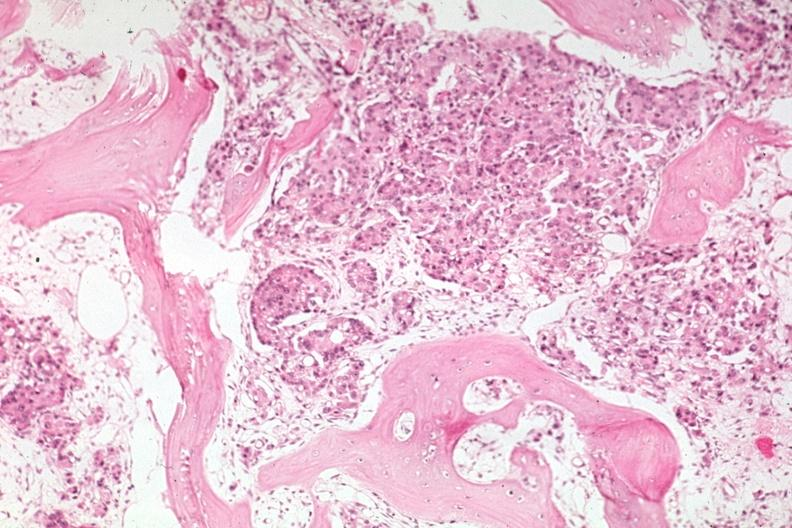what does this image show?
Answer the question using a single word or phrase. Med good carcinoma with some bone resorption 